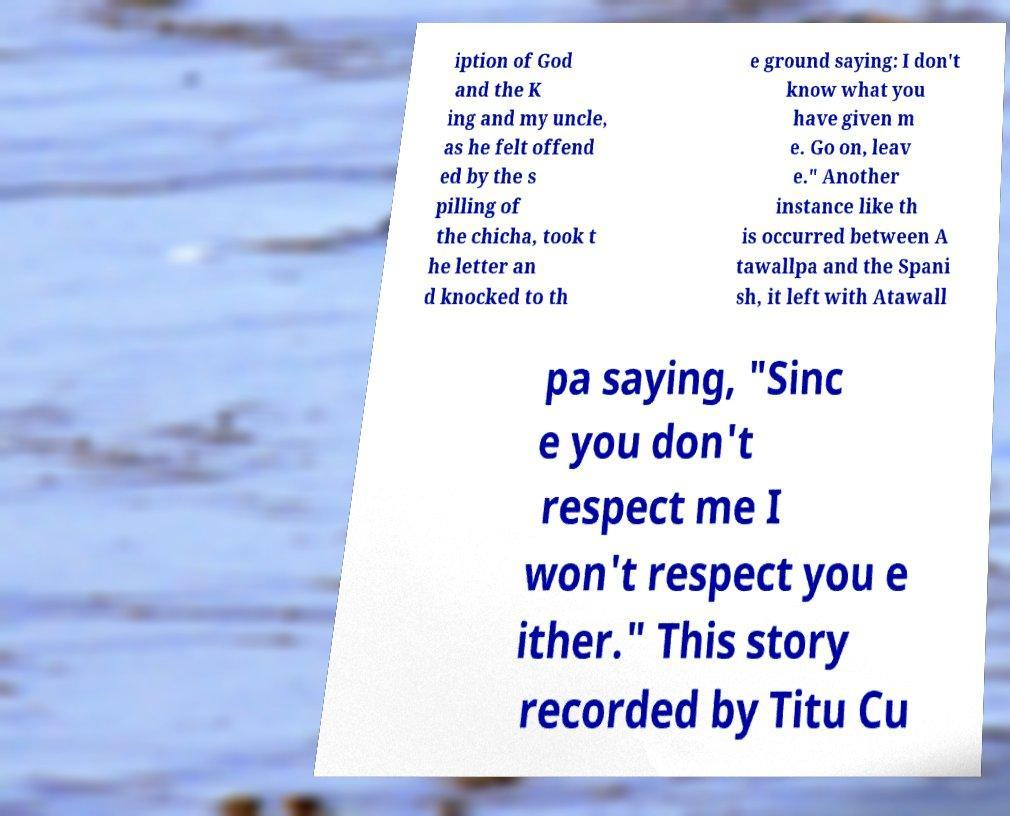There's text embedded in this image that I need extracted. Can you transcribe it verbatim? iption of God and the K ing and my uncle, as he felt offend ed by the s pilling of the chicha, took t he letter an d knocked to th e ground saying: I don't know what you have given m e. Go on, leav e." Another instance like th is occurred between A tawallpa and the Spani sh, it left with Atawall pa saying, "Sinc e you don't respect me I won't respect you e ither." This story recorded by Titu Cu 